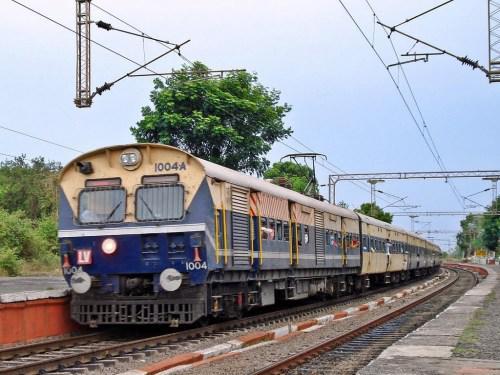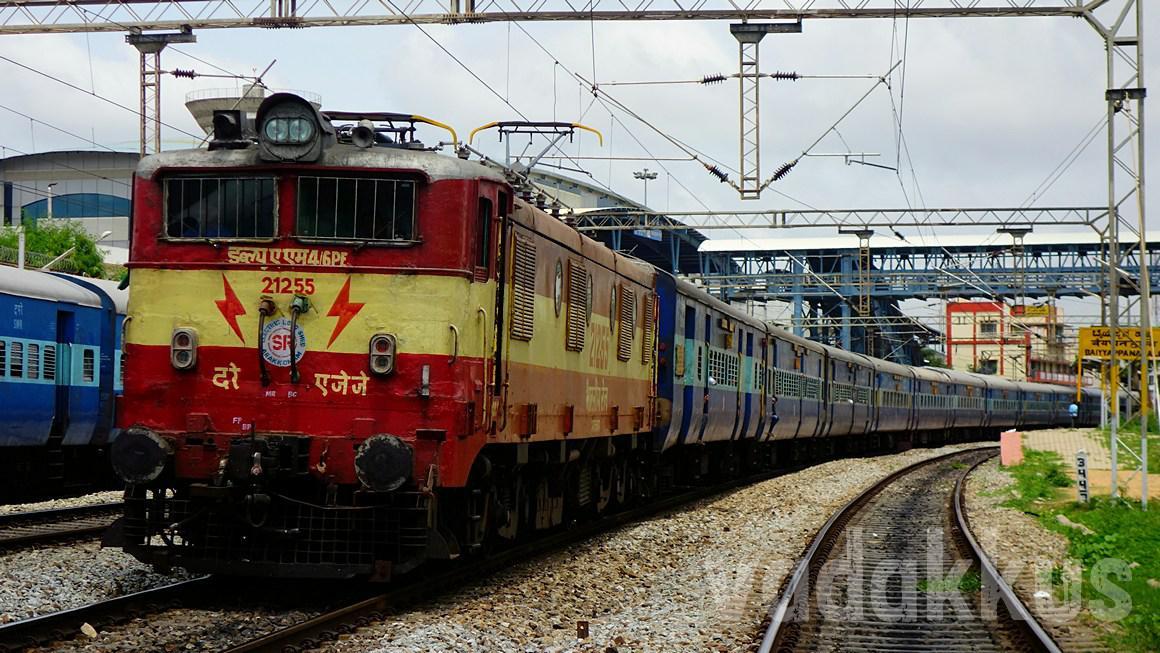The first image is the image on the left, the second image is the image on the right. Considering the images on both sides, is "The right image shows a train with the front car colored red and yellow." valid? Answer yes or no. Yes. 